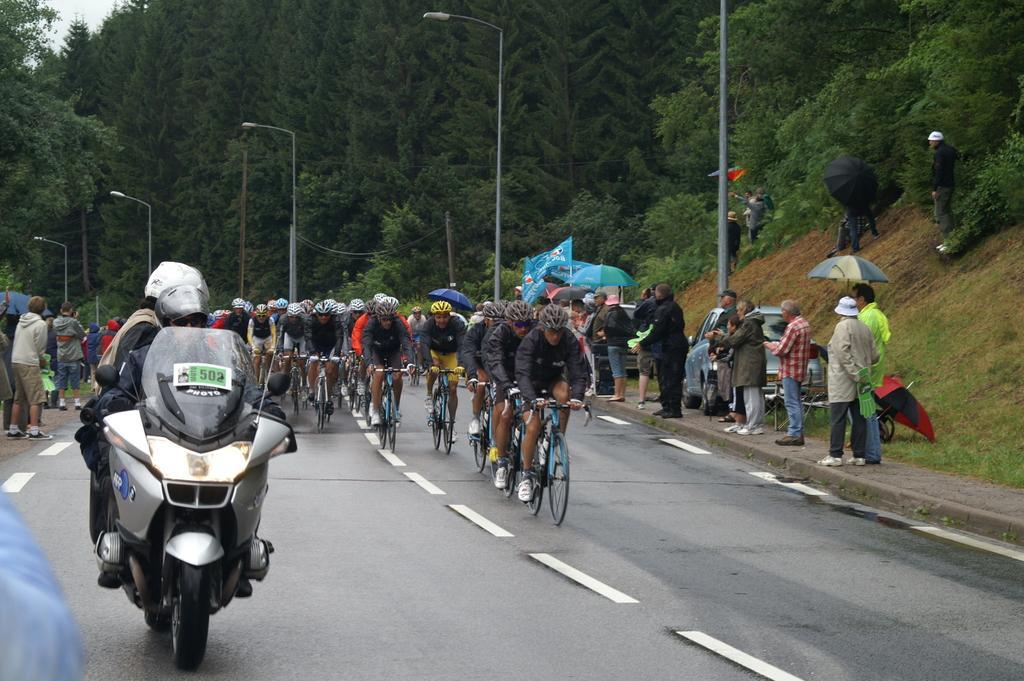Please provide a concise description of this image. In this image we can see the bicycle racing. We can also see some persons watching the race. On the left there is a person riding the motorbike. In the background we can see the light poles and also many trees. At the bottom there is road. 